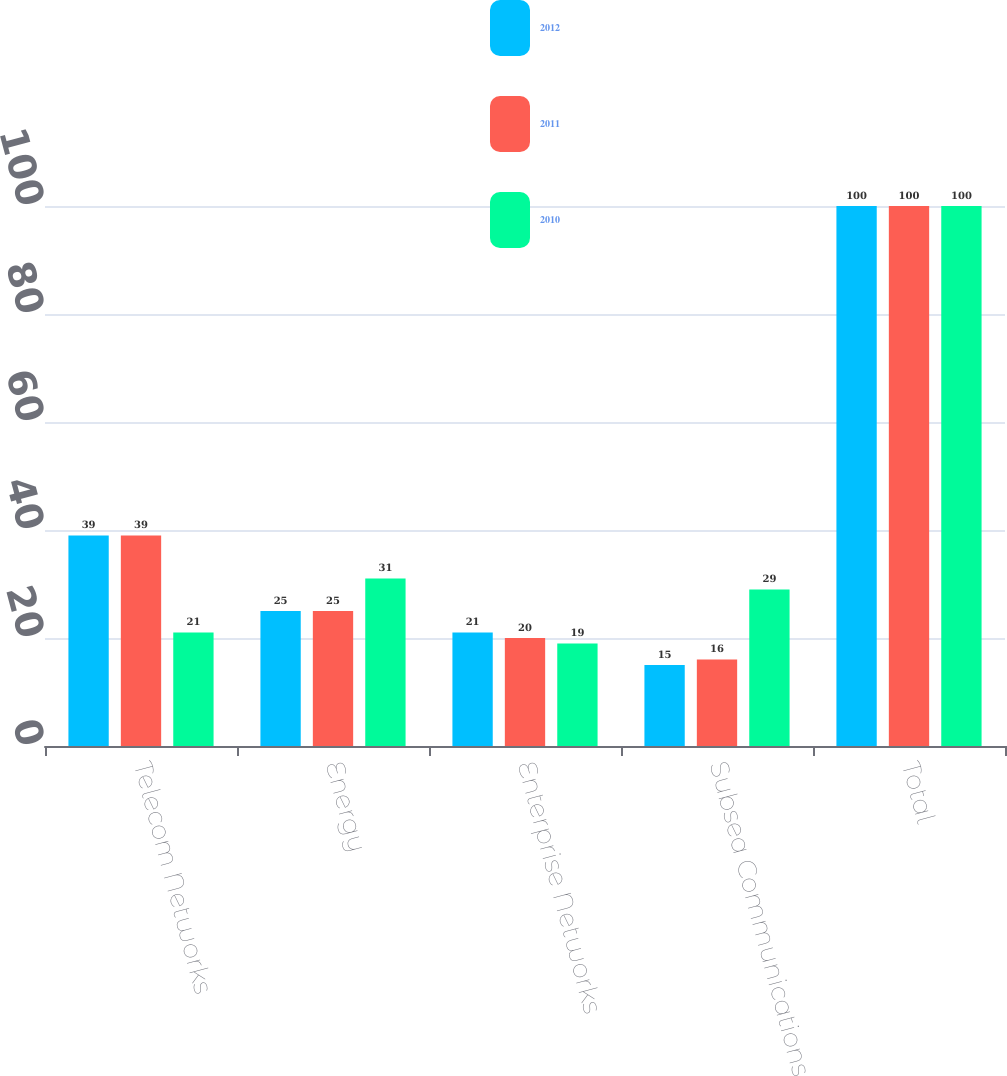Convert chart. <chart><loc_0><loc_0><loc_500><loc_500><stacked_bar_chart><ecel><fcel>Telecom Networks<fcel>Energy<fcel>Enterprise Networks<fcel>Subsea Communications<fcel>Total<nl><fcel>2012<fcel>39<fcel>25<fcel>21<fcel>15<fcel>100<nl><fcel>2011<fcel>39<fcel>25<fcel>20<fcel>16<fcel>100<nl><fcel>2010<fcel>21<fcel>31<fcel>19<fcel>29<fcel>100<nl></chart> 